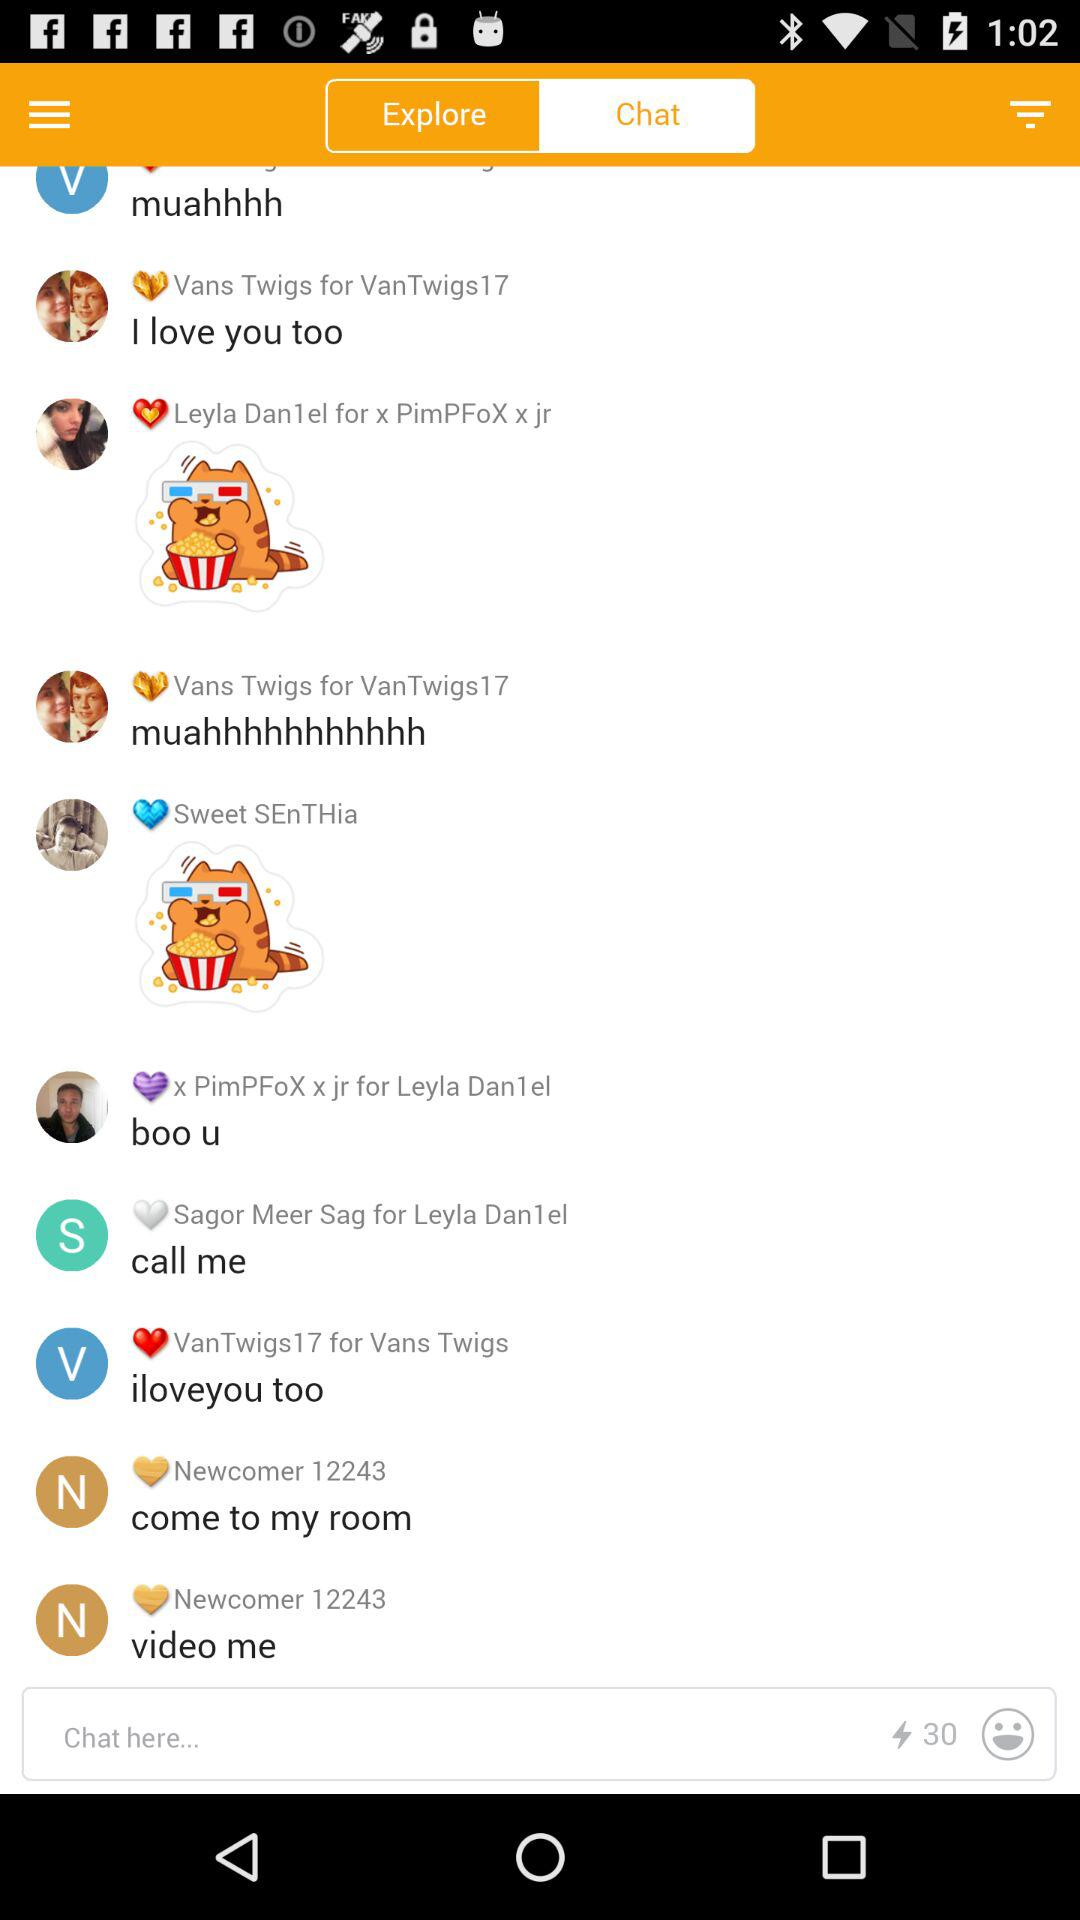Which tab is selected? The selected tab is "Chat". 